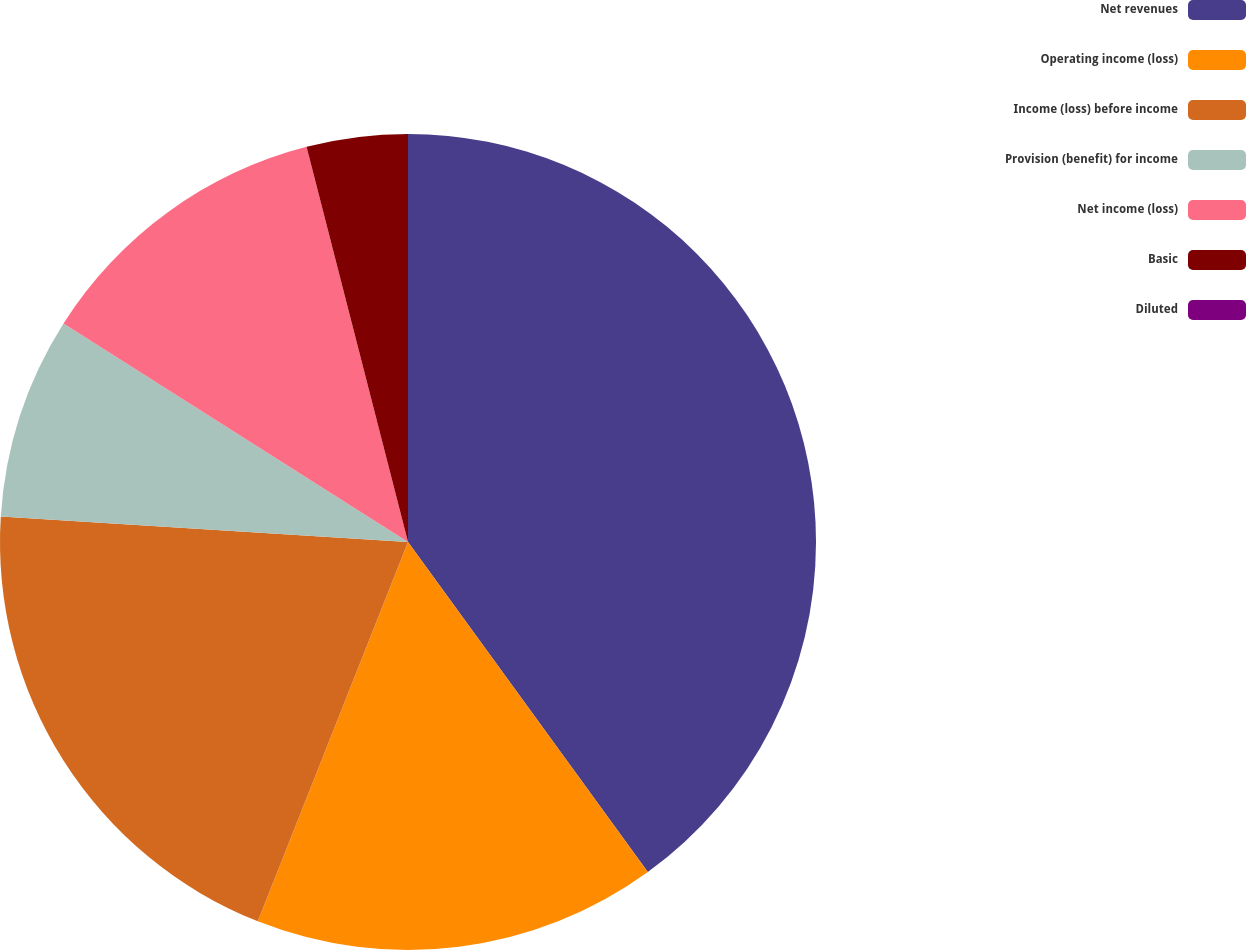<chart> <loc_0><loc_0><loc_500><loc_500><pie_chart><fcel>Net revenues<fcel>Operating income (loss)<fcel>Income (loss) before income<fcel>Provision (benefit) for income<fcel>Net income (loss)<fcel>Basic<fcel>Diluted<nl><fcel>40.0%<fcel>16.0%<fcel>20.0%<fcel>8.0%<fcel>12.0%<fcel>4.0%<fcel>0.0%<nl></chart> 